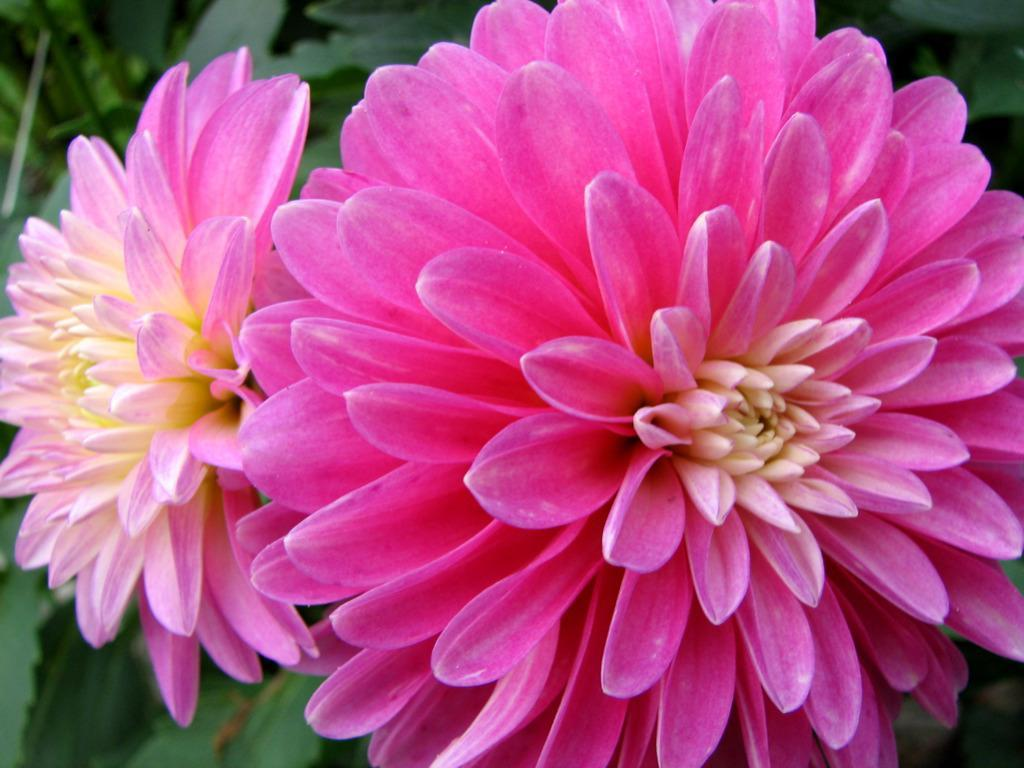How many flowers are present in the image? There are two flowers in the image. What colors are the flowers? One flower is pink, and the other is yellow. What can be seen in the background of the image? There are green leaves in the background of the image. What type of popcorn is being served in the image? There is no popcorn present in the image; it features two flowers and green leaves in the background. Is there a camera visible in the image? There is no camera present in the image. 